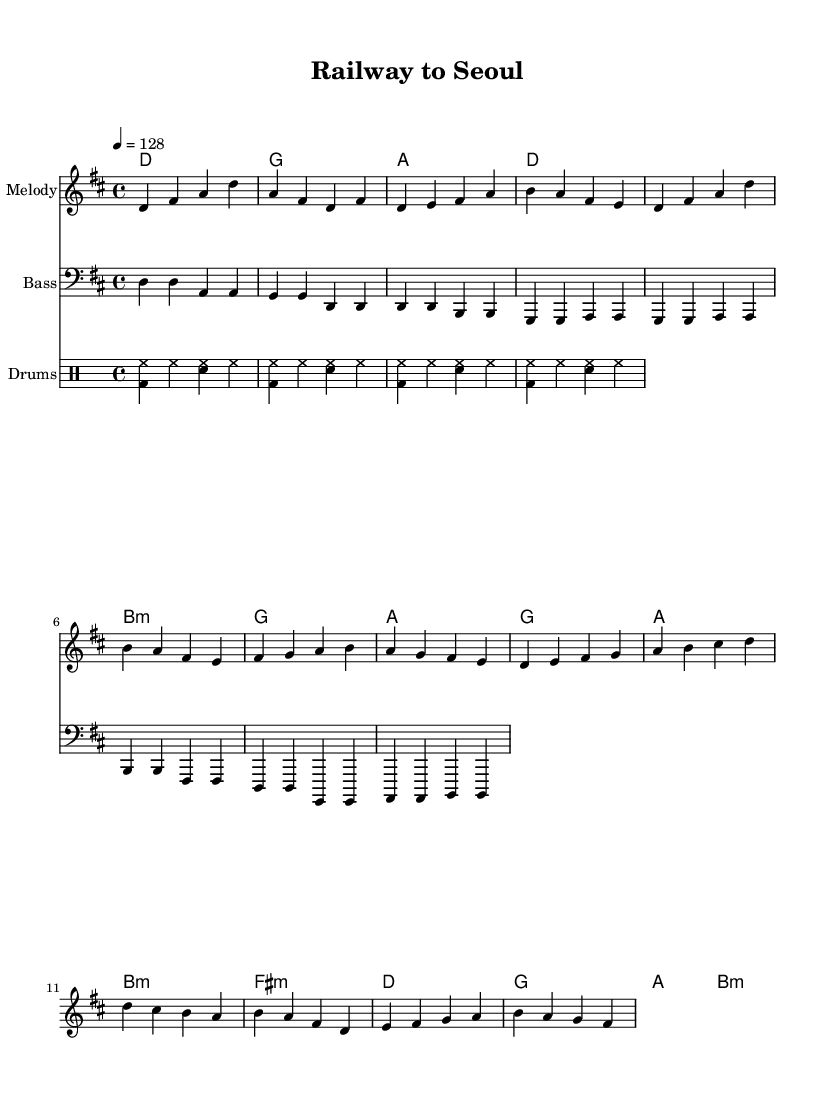What is the key signature of this music? The key signature is D major, which has two sharps (F# and C#). This can be observed by looking at the key signature indicated at the beginning of the score.
Answer: D major What is the time signature of this music? The time signature is 4/4, as indicated at the beginning of the score. This means there are four beats in each measure and the quarter note gets one beat.
Answer: 4/4 What is the tempo marking provided in the music? The tempo marking is 4 = 128 BPM, meaning the quarter note should be played at a speed of 128 beats per minute. This is indicated near the beginning of the score.
Answer: 128 How many measures are in the chorus section? The chorus section consists of four measures, which can be counted by looking at the grouping of notes in that section.
Answer: 4 What is the primary instrument for the melody in this music sheet? The primary instrument for the melody is denoted by the staff labeled "Melody," which indicates that it carries the main melodic line for the piece.
Answer: Melody Which section contains the train-sounding rhythm? The drum pattern section contains a rhythmic pattern that can resemble train sounds, specifically the bass drum (bd) pattern creating a chugging effect, typical of railway-inspired rhythms.
Answer: Drum Patterns 